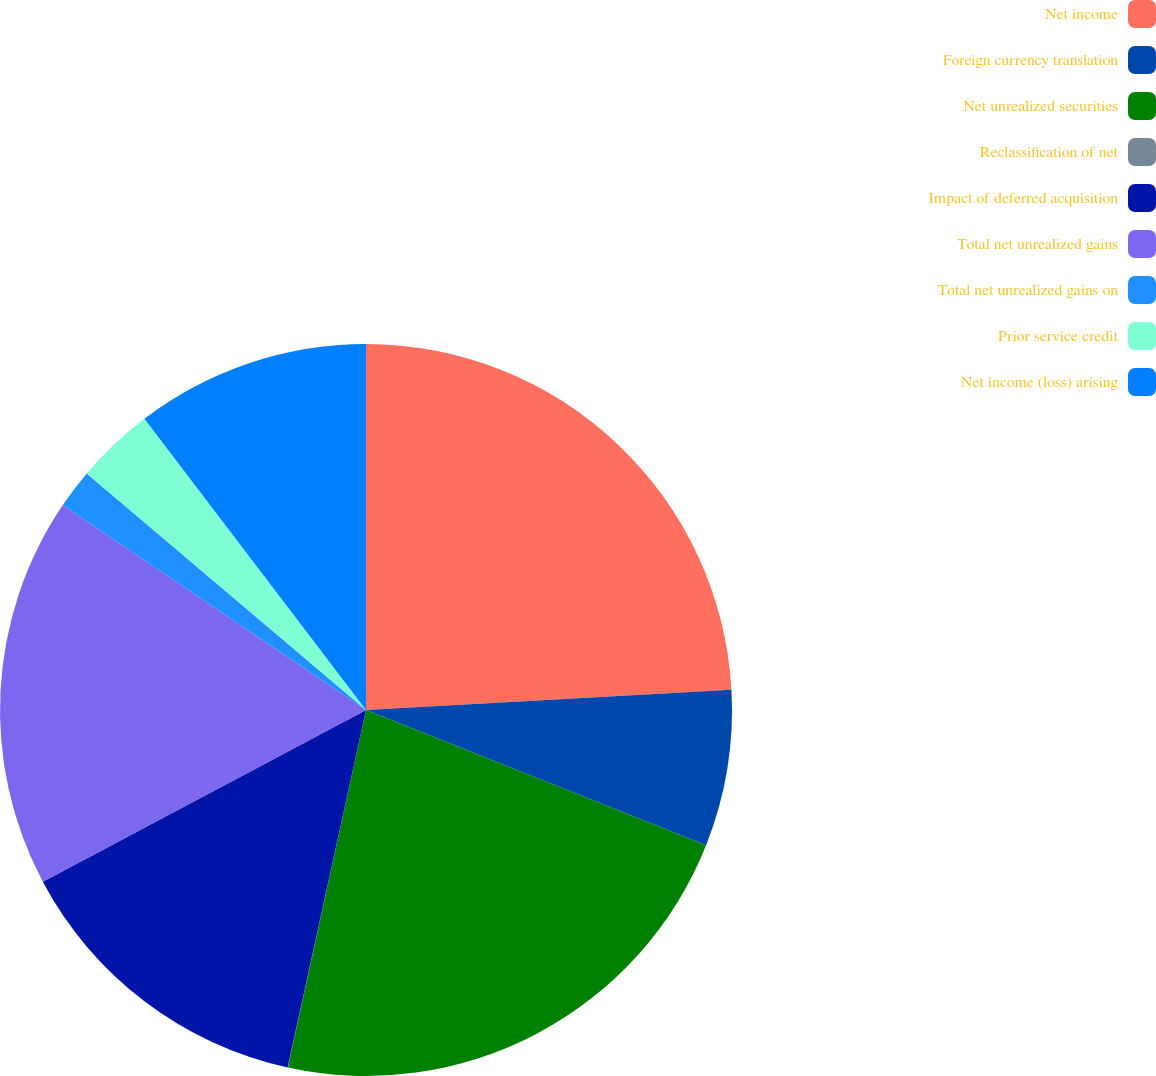Convert chart. <chart><loc_0><loc_0><loc_500><loc_500><pie_chart><fcel>Net income<fcel>Foreign currency translation<fcel>Net unrealized securities<fcel>Reclassification of net<fcel>Impact of deferred acquisition<fcel>Total net unrealized gains<fcel>Total net unrealized gains on<fcel>Prior service credit<fcel>Net income (loss) arising<nl><fcel>24.12%<fcel>6.9%<fcel>22.4%<fcel>0.01%<fcel>13.79%<fcel>17.23%<fcel>1.73%<fcel>3.46%<fcel>10.35%<nl></chart> 